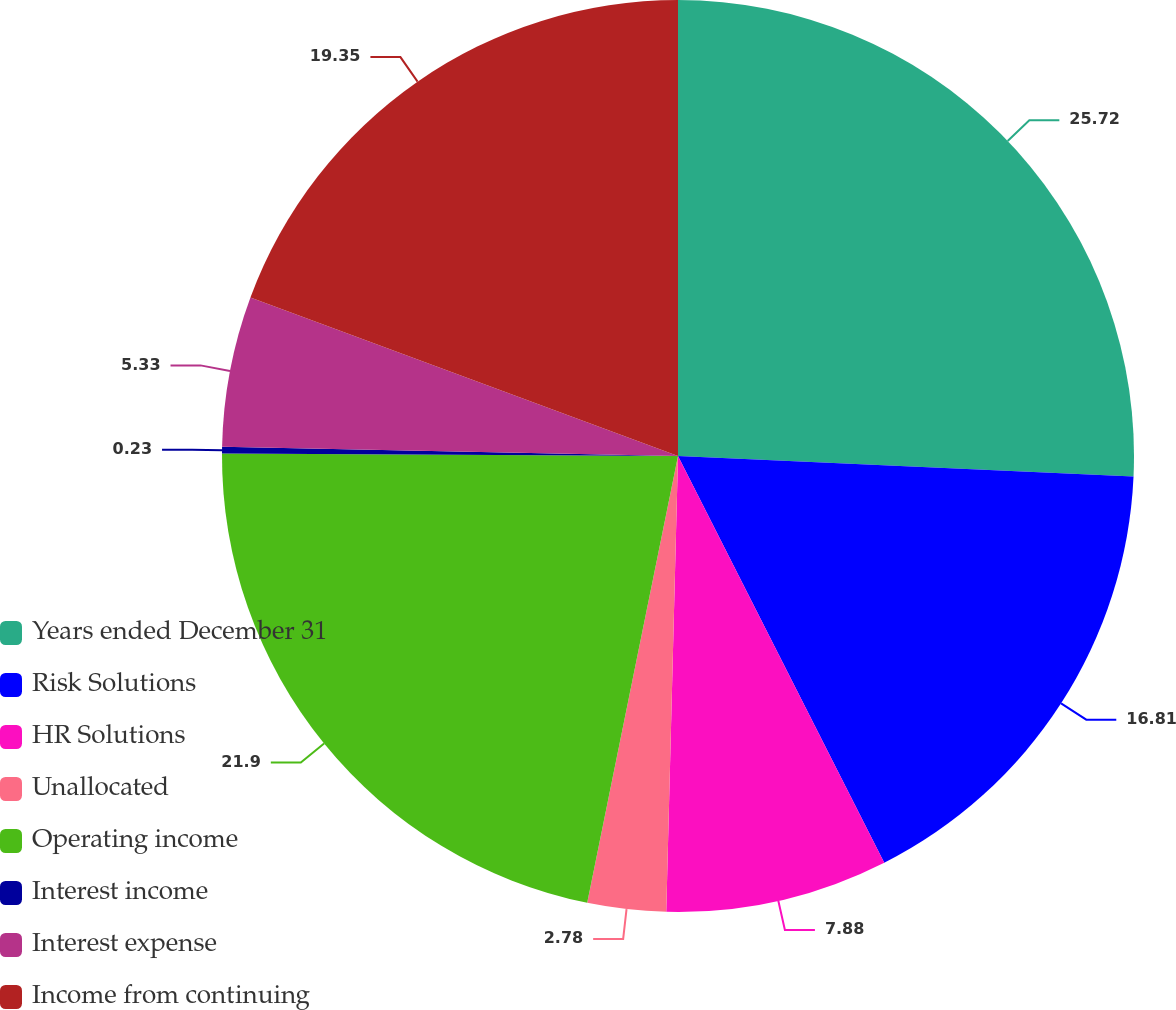Convert chart. <chart><loc_0><loc_0><loc_500><loc_500><pie_chart><fcel>Years ended December 31<fcel>Risk Solutions<fcel>HR Solutions<fcel>Unallocated<fcel>Operating income<fcel>Interest income<fcel>Interest expense<fcel>Income from continuing<nl><fcel>25.72%<fcel>16.81%<fcel>7.88%<fcel>2.78%<fcel>21.9%<fcel>0.23%<fcel>5.33%<fcel>19.35%<nl></chart> 